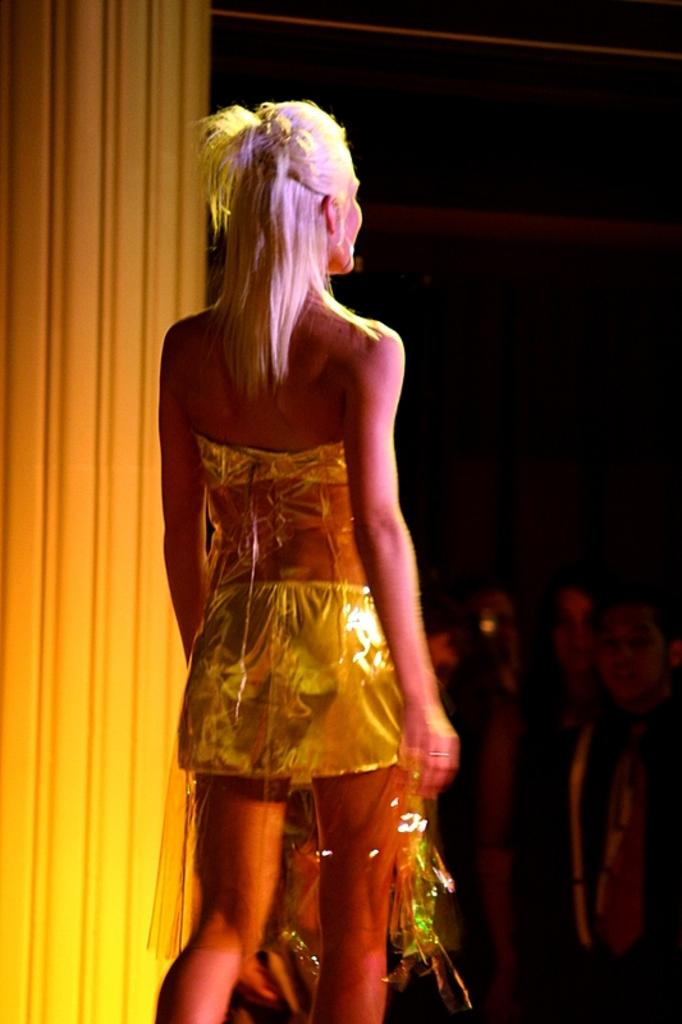What is the woman in the image doing? The woman is walking in the image. What can be seen behind the woman? There is a pillar behind the woman. How would you describe the overall lighting in the image? The background of the image is dark. Are there any other people visible in the image? Yes, there are a few people standing to the right of the image. What type of impulse is being generated by the brass sweater in the image? There is no brass sweater present in the image, and therefore no impulse can be generated by it. 